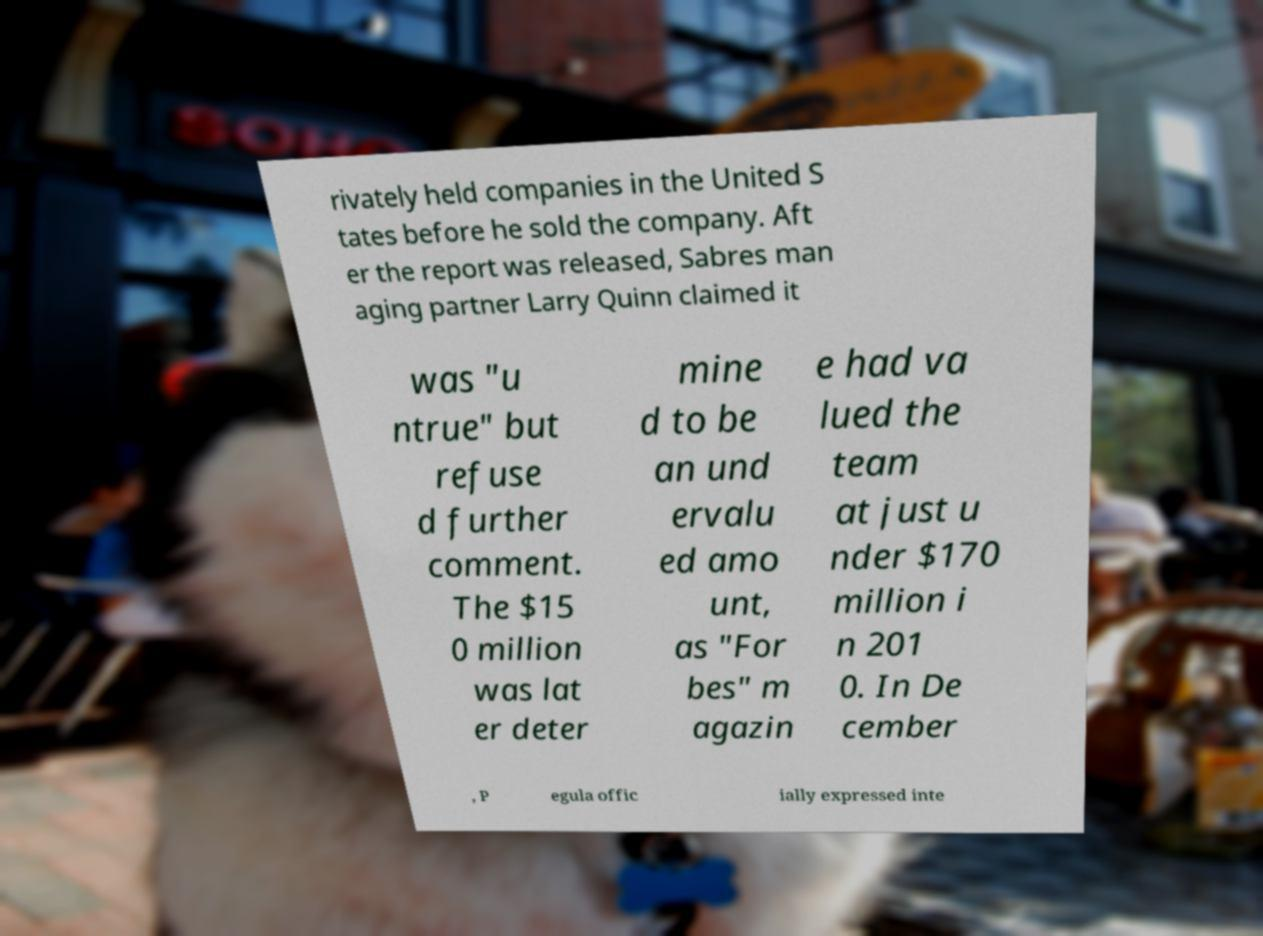For documentation purposes, I need the text within this image transcribed. Could you provide that? rivately held companies in the United S tates before he sold the company. Aft er the report was released, Sabres man aging partner Larry Quinn claimed it was "u ntrue" but refuse d further comment. The $15 0 million was lat er deter mine d to be an und ervalu ed amo unt, as "For bes" m agazin e had va lued the team at just u nder $170 million i n 201 0. In De cember , P egula offic ially expressed inte 